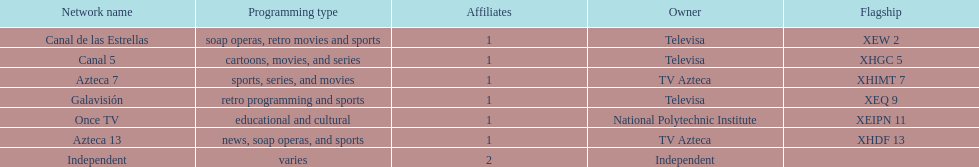What is the total number of affiliates among all the networks? 8. 